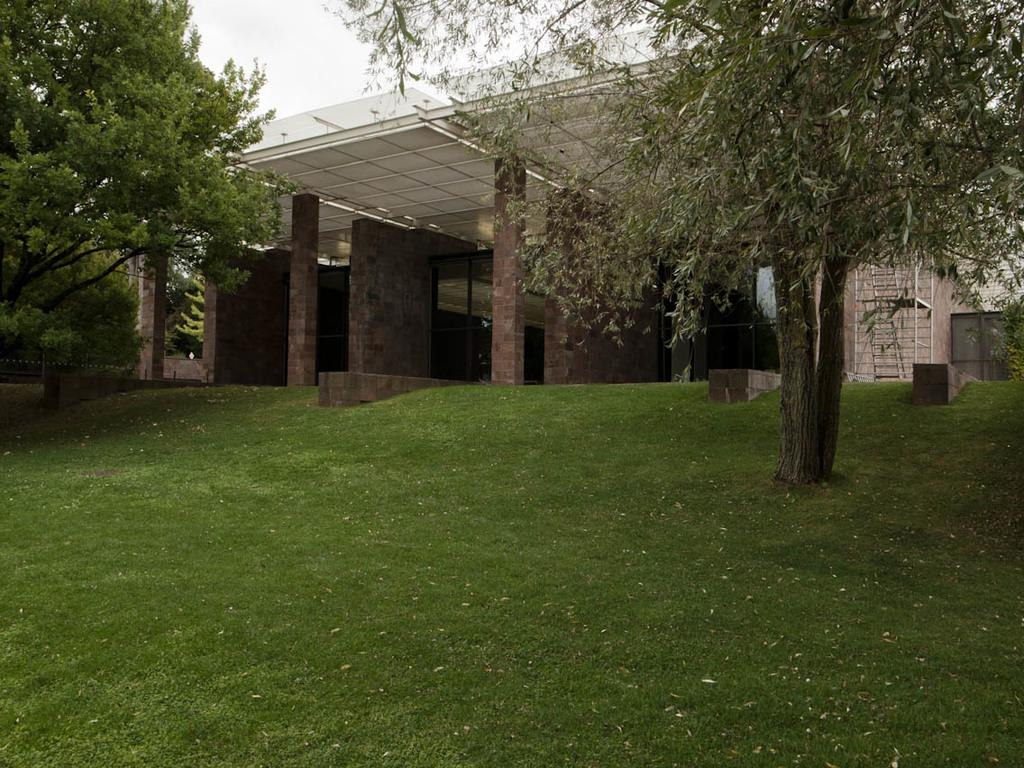What type of structure is present in the image? There is a building with pillars in the image. What other natural elements can be seen in the image? There is a group of trees in the image. Where is the staircase located in the image? The staircase is on the right side of the image. What can be seen in the background of the image? The sky is visible in the background of the image. What type of music can be heard coming from the building in the image? There is no indication of music or any sounds in the image, so it's not possible to determine what, if any, music might be heard. 